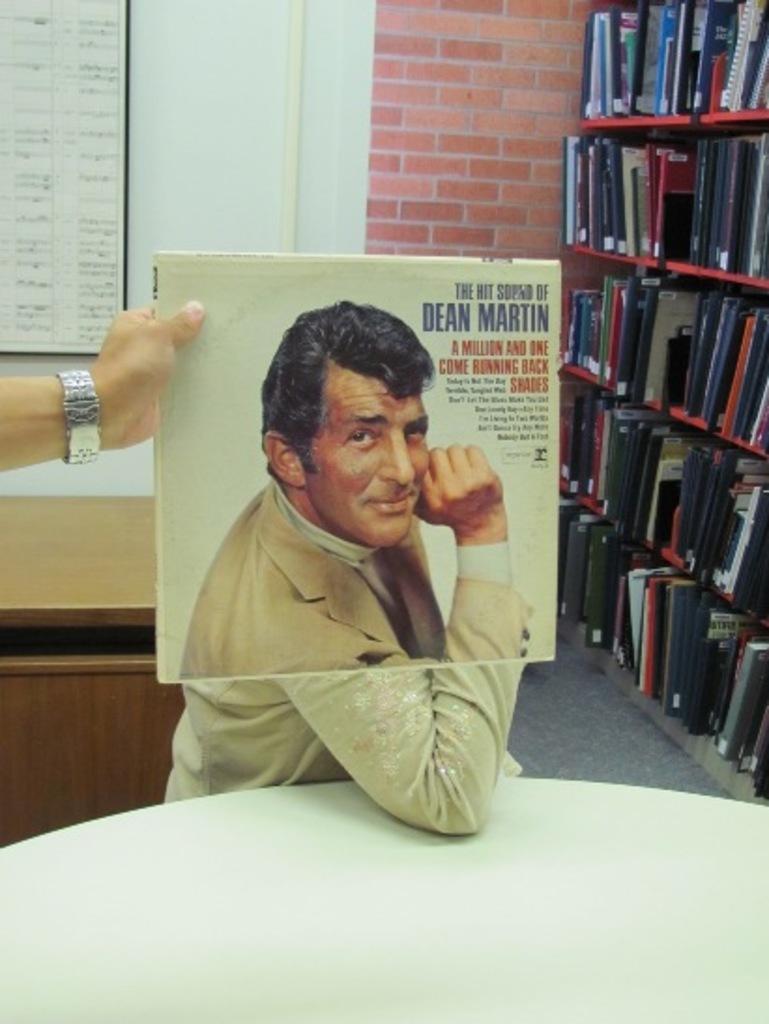What artist is this album from?
Offer a very short reply. Dean martin. Whos name is printed on the vinyl cover?
Your answer should be compact. Dean martin. 